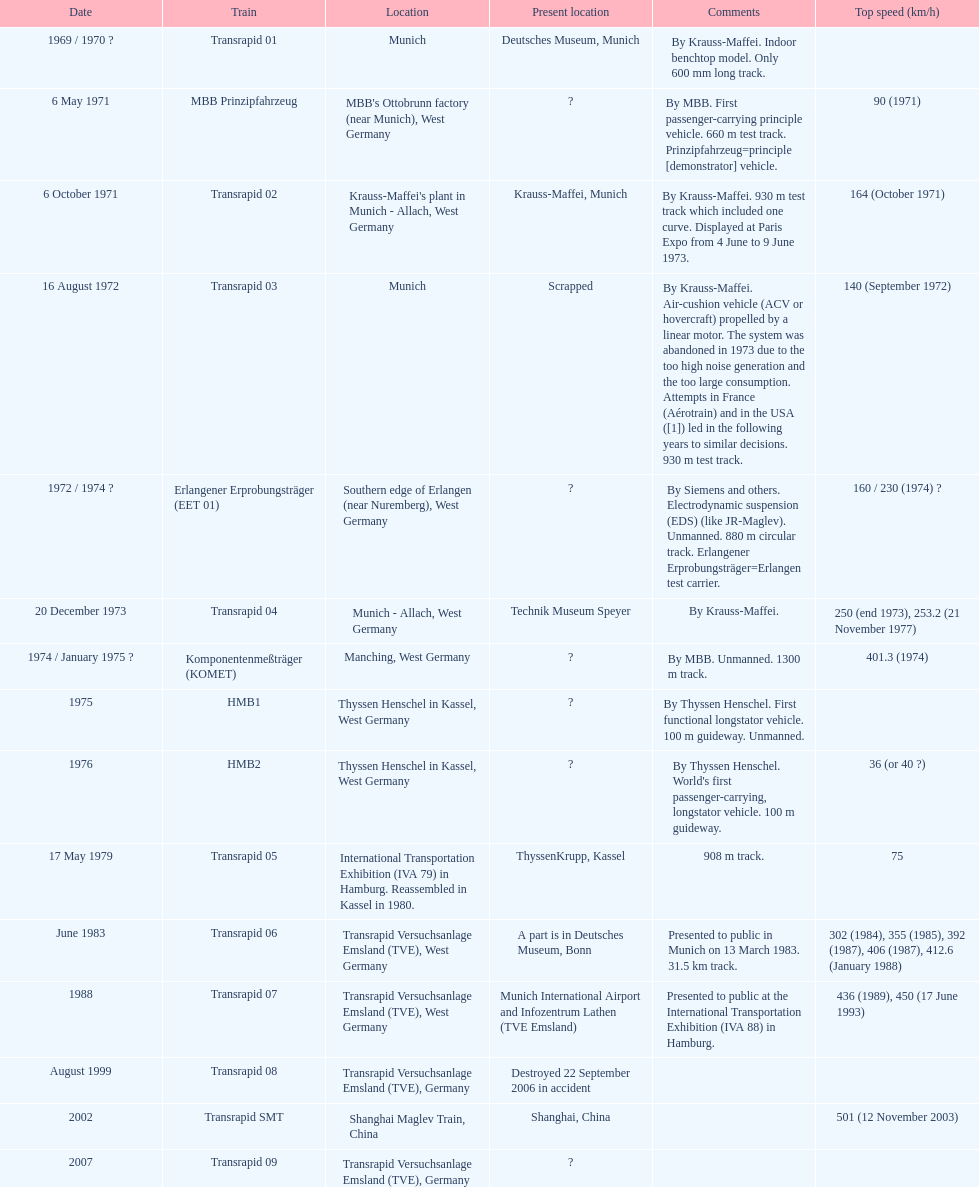What is the total of trains that were either disassembled or destroyed? 2. Would you be able to parse every entry in this table? {'header': ['Date', 'Train', 'Location', 'Present location', 'Comments', 'Top speed (km/h)'], 'rows': [['1969 / 1970\xa0?', 'Transrapid 01', 'Munich', 'Deutsches Museum, Munich', 'By Krauss-Maffei. Indoor benchtop model. Only 600\xa0mm long track.', ''], ['6 May 1971', 'MBB Prinzipfahrzeug', "MBB's Ottobrunn factory (near Munich), West Germany", '?', 'By MBB. First passenger-carrying principle vehicle. 660 m test track. Prinzipfahrzeug=principle [demonstrator] vehicle.', '90 (1971)'], ['6 October 1971', 'Transrapid 02', "Krauss-Maffei's plant in Munich - Allach, West Germany", 'Krauss-Maffei, Munich', 'By Krauss-Maffei. 930 m test track which included one curve. Displayed at Paris Expo from 4 June to 9 June 1973.', '164 (October 1971)'], ['16 August 1972', 'Transrapid 03', 'Munich', 'Scrapped', 'By Krauss-Maffei. Air-cushion vehicle (ACV or hovercraft) propelled by a linear motor. The system was abandoned in 1973 due to the too high noise generation and the too large consumption. Attempts in France (Aérotrain) and in the USA ([1]) led in the following years to similar decisions. 930 m test track.', '140 (September 1972)'], ['1972 / 1974\xa0?', 'Erlangener Erprobungsträger (EET 01)', 'Southern edge of Erlangen (near Nuremberg), West Germany', '?', 'By Siemens and others. Electrodynamic suspension (EDS) (like JR-Maglev). Unmanned. 880 m circular track. Erlangener Erprobungsträger=Erlangen test carrier.', '160 / 230 (1974)\xa0?'], ['20 December 1973', 'Transrapid 04', 'Munich - Allach, West Germany', 'Technik Museum Speyer', 'By Krauss-Maffei.', '250 (end 1973), 253.2 (21 November 1977)'], ['1974 / January 1975\xa0?', 'Komponentenmeßträger (KOMET)', 'Manching, West Germany', '?', 'By MBB. Unmanned. 1300 m track.', '401.3 (1974)'], ['1975', 'HMB1', 'Thyssen Henschel in Kassel, West Germany', '?', 'By Thyssen Henschel. First functional longstator vehicle. 100 m guideway. Unmanned.', ''], ['1976', 'HMB2', 'Thyssen Henschel in Kassel, West Germany', '?', "By Thyssen Henschel. World's first passenger-carrying, longstator vehicle. 100 m guideway.", '36 (or 40\xa0?)'], ['17 May 1979', 'Transrapid 05', 'International Transportation Exhibition (IVA 79) in Hamburg. Reassembled in Kassel in 1980.', 'ThyssenKrupp, Kassel', '908 m track.', '75'], ['June 1983', 'Transrapid 06', 'Transrapid Versuchsanlage Emsland (TVE), West Germany', 'A part is in Deutsches Museum, Bonn', 'Presented to public in Munich on 13 March 1983. 31.5\xa0km track.', '302 (1984), 355 (1985), 392 (1987), 406 (1987), 412.6 (January 1988)'], ['1988', 'Transrapid 07', 'Transrapid Versuchsanlage Emsland (TVE), West Germany', 'Munich International Airport and Infozentrum Lathen (TVE Emsland)', 'Presented to public at the International Transportation Exhibition (IVA 88) in Hamburg.', '436 (1989), 450 (17 June 1993)'], ['August 1999', 'Transrapid 08', 'Transrapid Versuchsanlage Emsland (TVE), Germany', 'Destroyed 22 September 2006 in accident', '', ''], ['2002', 'Transrapid SMT', 'Shanghai Maglev Train, China', 'Shanghai, China', '', '501 (12 November 2003)'], ['2007', 'Transrapid 09', 'Transrapid Versuchsanlage Emsland (TVE), Germany', '?', '', '']]} 